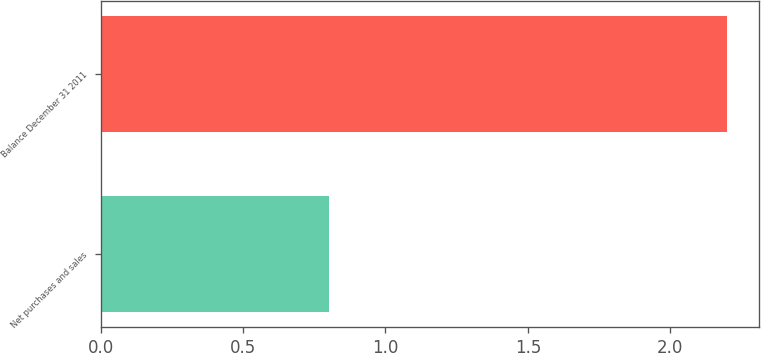Convert chart. <chart><loc_0><loc_0><loc_500><loc_500><bar_chart><fcel>Net purchases and sales<fcel>Balance December 31 2011<nl><fcel>0.8<fcel>2.2<nl></chart> 